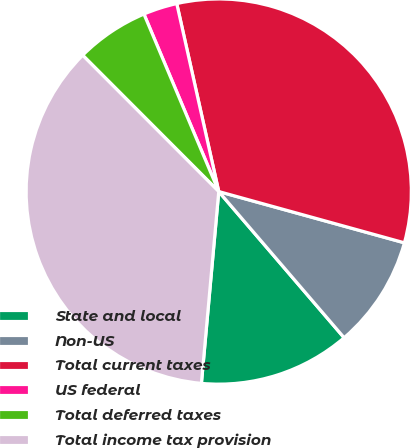<chart> <loc_0><loc_0><loc_500><loc_500><pie_chart><fcel>State and local<fcel>Non-US<fcel>Total current taxes<fcel>US federal<fcel>Total deferred taxes<fcel>Total income tax provision<nl><fcel>12.72%<fcel>9.43%<fcel>32.79%<fcel>2.85%<fcel>6.14%<fcel>36.08%<nl></chart> 